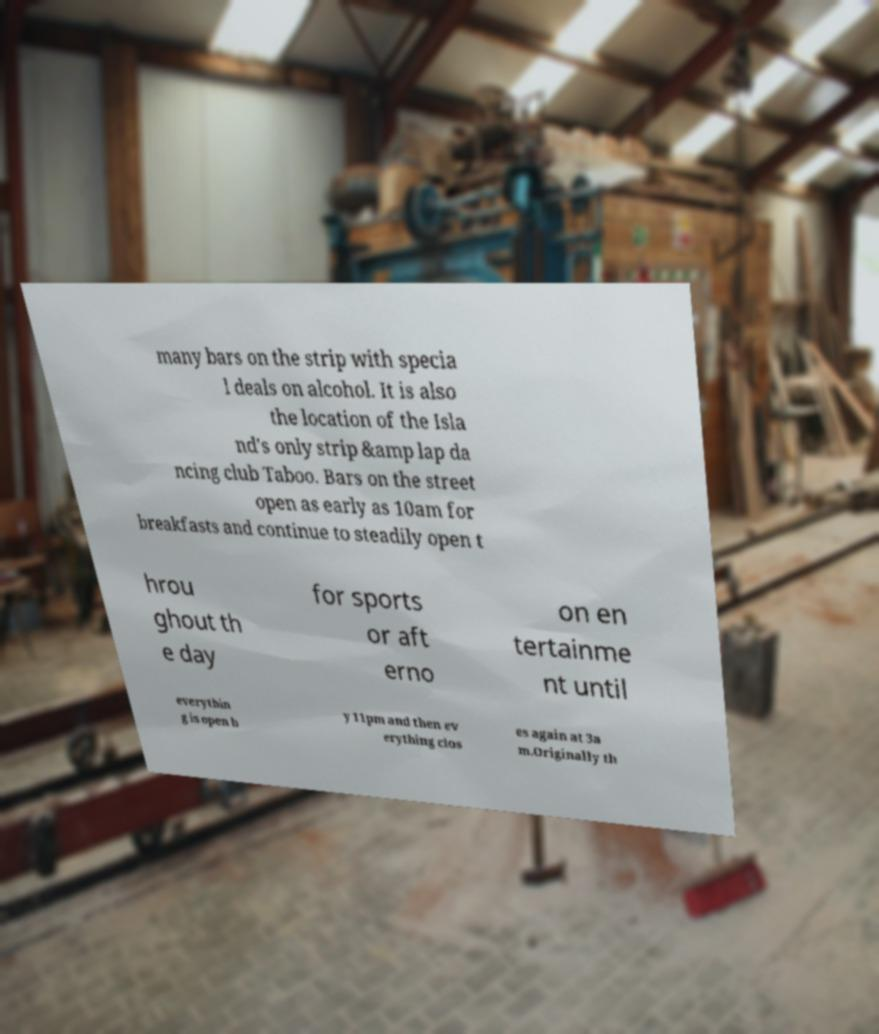Can you read and provide the text displayed in the image?This photo seems to have some interesting text. Can you extract and type it out for me? many bars on the strip with specia l deals on alcohol. It is also the location of the Isla nd's only strip &amp lap da ncing club Taboo. Bars on the street open as early as 10am for breakfasts and continue to steadily open t hrou ghout th e day for sports or aft erno on en tertainme nt until everythin g is open b y 11pm and then ev erything clos es again at 3a m.Originally th 